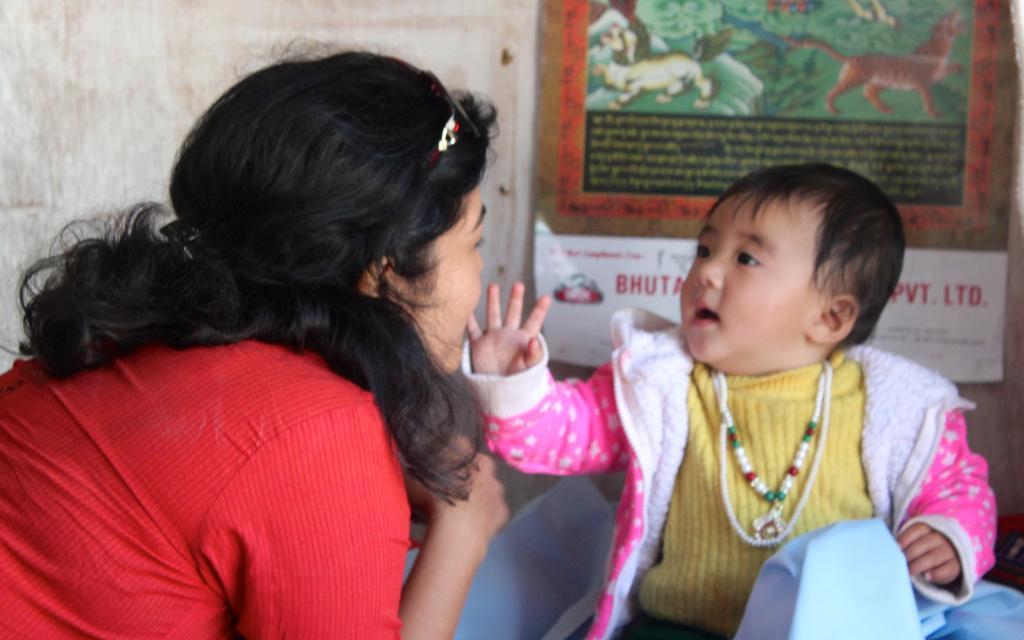Could you give a brief overview of what you see in this image? As we can see in the image there are two people, poster and a white color wall. 